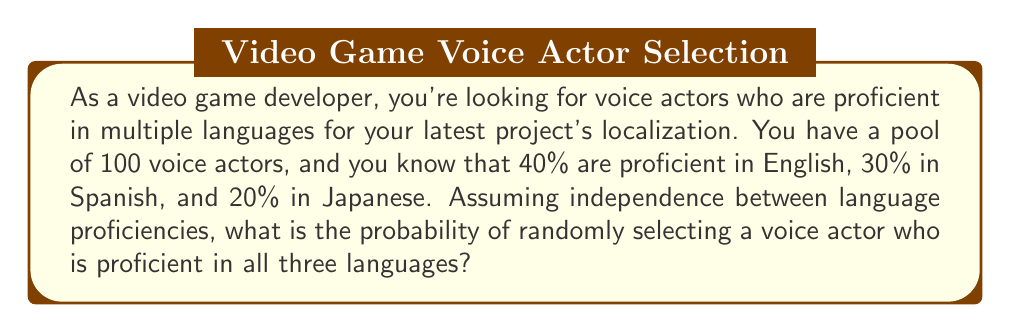Can you answer this question? To solve this problem, we need to use the concept of independent events and multiplication rule of probability.

Let's define the events:
$E$: Proficient in English
$S$: Proficient in Spanish
$J$: Proficient in Japanese

Given:
$P(E) = 0.40$
$P(S) = 0.30$
$P(J) = 0.20$

We want to find $P(E \cap S \cap J)$, the probability of a voice actor being proficient in all three languages.

Since we assume independence between language proficiencies, we can use the multiplication rule of probability:

$$P(E \cap S \cap J) = P(E) \times P(S) \times P(J)$$

Substituting the given probabilities:

$$P(E \cap S \cap J) = 0.40 \times 0.30 \times 0.20$$

$$P(E \cap S \cap J) = 0.024$$

To convert this to a percentage:

$$0.024 \times 100\% = 2.4\%$$

Therefore, the probability of randomly selecting a voice actor proficient in all three languages is 2.4% or 0.024.
Answer: The probability of randomly selecting a voice actor proficient in English, Spanish, and Japanese is 0.024 or 2.4%. 